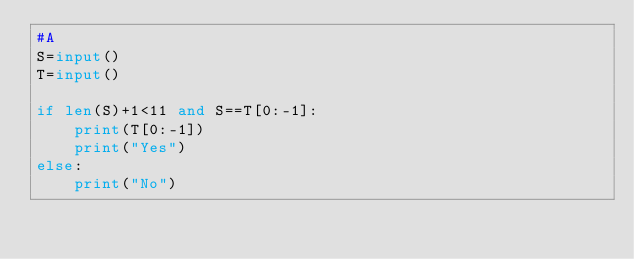<code> <loc_0><loc_0><loc_500><loc_500><_Python_>#A
S=input()
T=input()

if len(S)+1<11 and S==T[0:-1]:
    print(T[0:-1])
    print("Yes")
else:
    print("No")</code> 